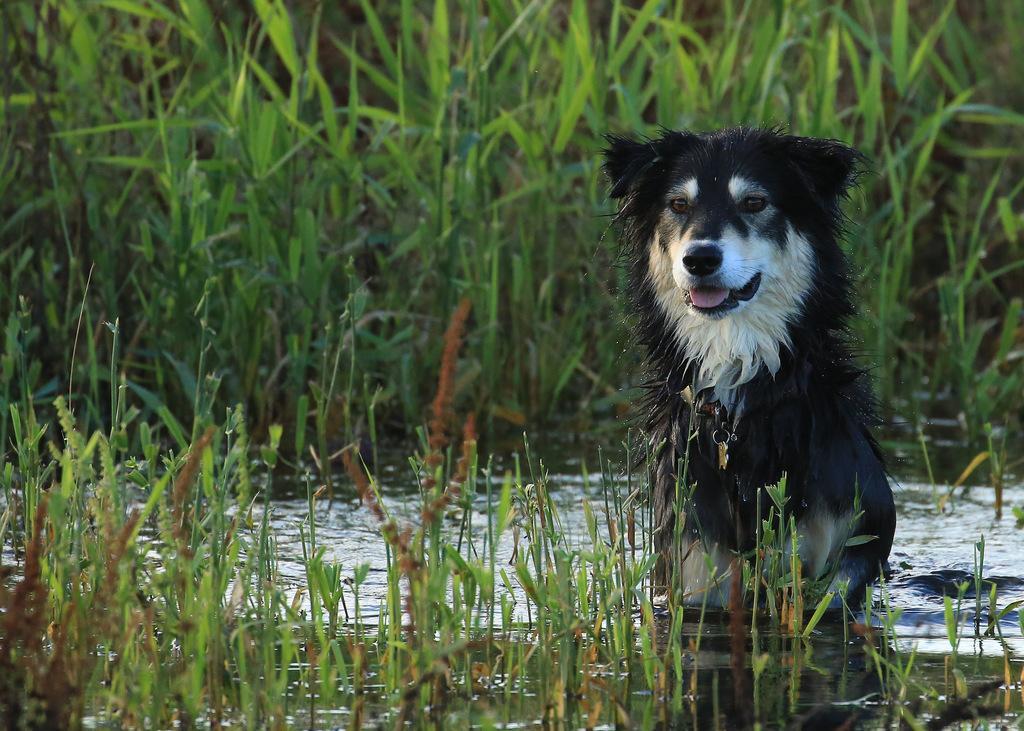How would you summarize this image in a sentence or two? In this image there is a dog in the water, around the dog there is a grass. 